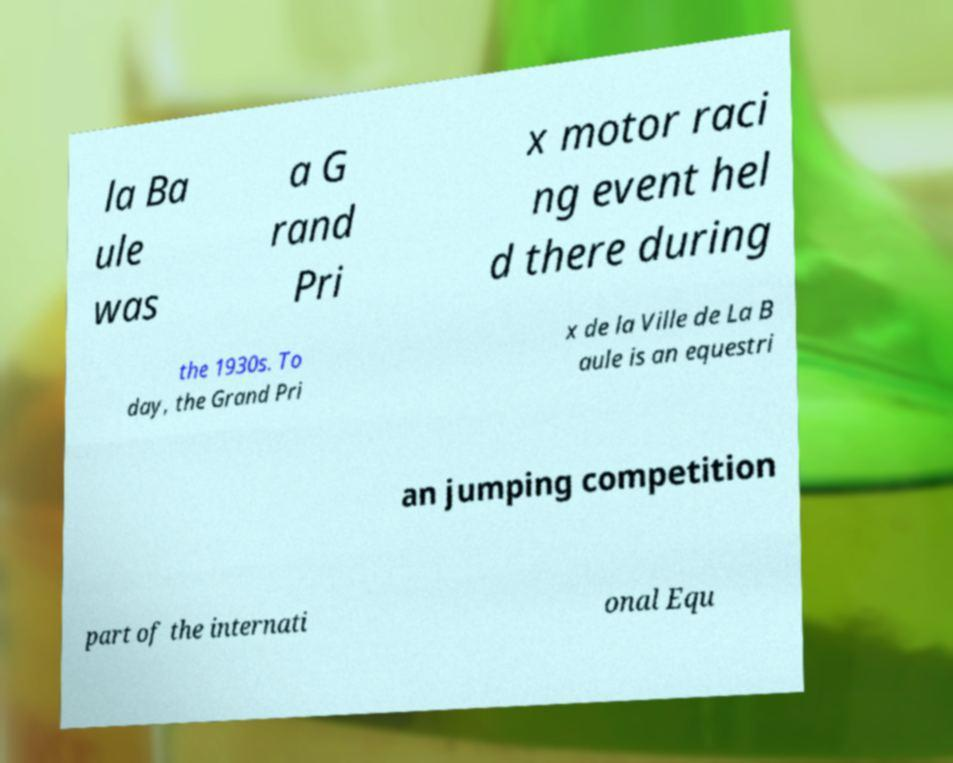There's text embedded in this image that I need extracted. Can you transcribe it verbatim? la Ba ule was a G rand Pri x motor raci ng event hel d there during the 1930s. To day, the Grand Pri x de la Ville de La B aule is an equestri an jumping competition part of the internati onal Equ 